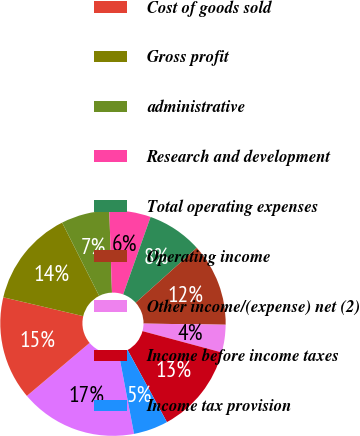Convert chart to OTSL. <chart><loc_0><loc_0><loc_500><loc_500><pie_chart><fcel>Net sales<fcel>Cost of goods sold<fcel>Gross profit<fcel>administrative<fcel>Research and development<fcel>Total operating expenses<fcel>Operating income<fcel>Other income/(expense) net (2)<fcel>Income before income taxes<fcel>Income tax provision<nl><fcel>16.83%<fcel>14.85%<fcel>13.86%<fcel>6.93%<fcel>5.94%<fcel>7.92%<fcel>11.88%<fcel>3.96%<fcel>12.87%<fcel>4.95%<nl></chart> 